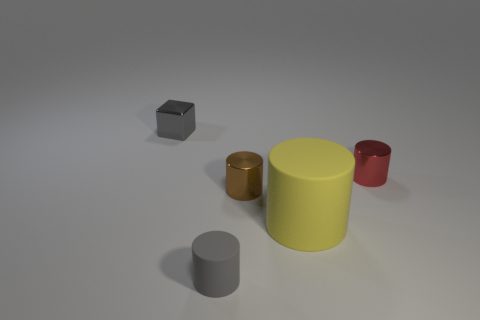What is the shape of the matte thing that is right of the brown object?
Offer a terse response. Cylinder. There is a small gray thing that is in front of the tiny gray metallic block; is its shape the same as the small brown object?
Provide a short and direct response. Yes. What number of things are either tiny metal objects on the left side of the small red shiny object or small red objects?
Ensure brevity in your answer.  3. There is a tiny matte object that is the same shape as the large yellow thing; what color is it?
Your response must be concise. Gray. Are there any other things of the same color as the large matte cylinder?
Offer a very short reply. No. There is a shiny thing left of the small brown cylinder; what size is it?
Offer a terse response. Small. Is the color of the small matte cylinder the same as the metal cylinder that is on the right side of the big object?
Your answer should be very brief. No. What number of other things are there of the same material as the brown cylinder
Your response must be concise. 2. Is the number of rubber things greater than the number of tiny gray rubber things?
Your answer should be very brief. Yes. Does the small object that is to the left of the small gray rubber cylinder have the same color as the small rubber cylinder?
Make the answer very short. Yes. 